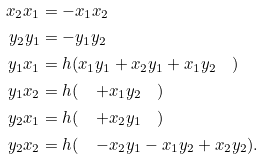Convert formula to latex. <formula><loc_0><loc_0><loc_500><loc_500>x _ { 2 } x _ { 1 } & = - x _ { 1 } x _ { 2 } \\ y _ { 2 } y _ { 1 } & = - y _ { 1 } y _ { 2 } \\ y _ { 1 } x _ { 1 } & = h ( x _ { 1 } y _ { 1 } + x _ { 2 } y _ { 1 } + x _ { 1 } y _ { 2 } \quad ) \\ y _ { 1 } x _ { 2 } & = h ( \quad \, + x _ { 1 } y _ { 2 } \quad ) \\ y _ { 2 } x _ { 1 } & = h ( \quad \, + x _ { 2 } y _ { 1 } \quad ) \\ y _ { 2 } x _ { 2 } & = h ( \quad \, - x _ { 2 } y _ { 1 } - x _ { 1 } y _ { 2 } + x _ { 2 } y _ { 2 } ) .</formula> 